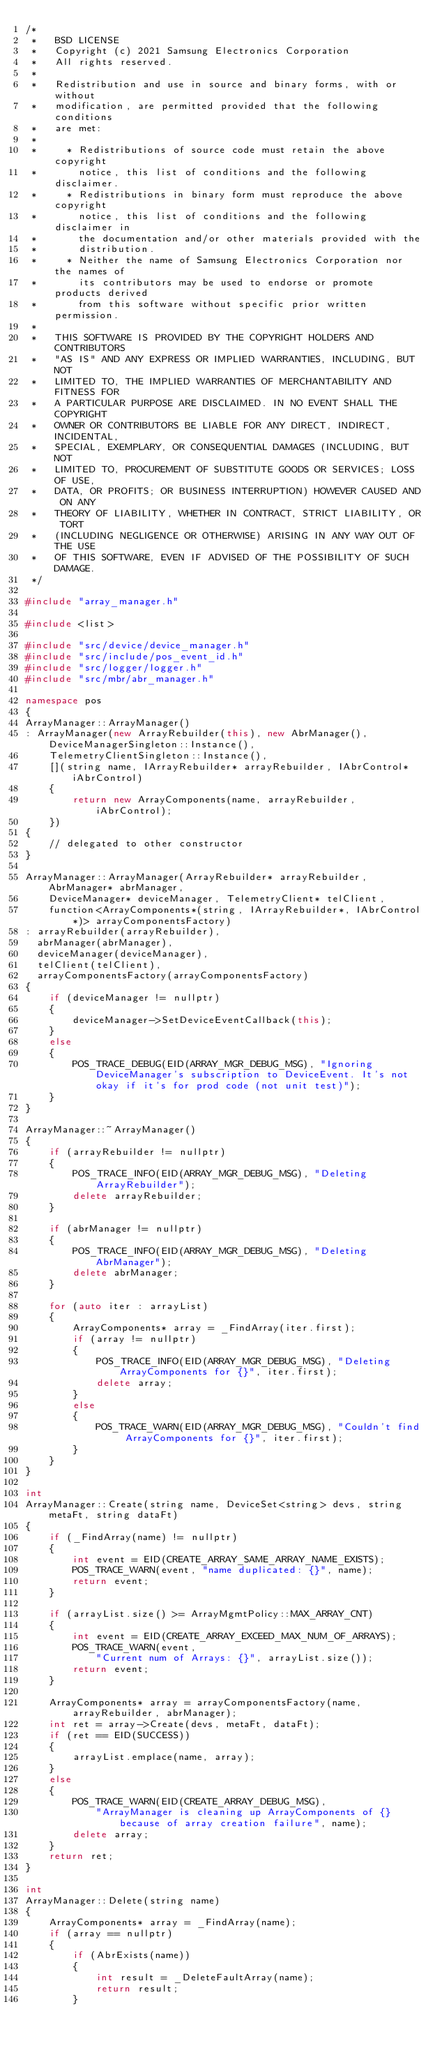<code> <loc_0><loc_0><loc_500><loc_500><_C++_>/*
 *   BSD LICENSE
 *   Copyright (c) 2021 Samsung Electronics Corporation
 *   All rights reserved.
 *
 *   Redistribution and use in source and binary forms, with or without
 *   modification, are permitted provided that the following conditions
 *   are met:
 *
 *     * Redistributions of source code must retain the above copyright
 *       notice, this list of conditions and the following disclaimer.
 *     * Redistributions in binary form must reproduce the above copyright
 *       notice, this list of conditions and the following disclaimer in
 *       the documentation and/or other materials provided with the
 *       distribution.
 *     * Neither the name of Samsung Electronics Corporation nor the names of
 *       its contributors may be used to endorse or promote products derived
 *       from this software without specific prior written permission.
 *
 *   THIS SOFTWARE IS PROVIDED BY THE COPYRIGHT HOLDERS AND CONTRIBUTORS
 *   "AS IS" AND ANY EXPRESS OR IMPLIED WARRANTIES, INCLUDING, BUT NOT
 *   LIMITED TO, THE IMPLIED WARRANTIES OF MERCHANTABILITY AND FITNESS FOR
 *   A PARTICULAR PURPOSE ARE DISCLAIMED. IN NO EVENT SHALL THE COPYRIGHT
 *   OWNER OR CONTRIBUTORS BE LIABLE FOR ANY DIRECT, INDIRECT, INCIDENTAL,
 *   SPECIAL, EXEMPLARY, OR CONSEQUENTIAL DAMAGES (INCLUDING, BUT NOT
 *   LIMITED TO, PROCUREMENT OF SUBSTITUTE GOODS OR SERVICES; LOSS OF USE,
 *   DATA, OR PROFITS; OR BUSINESS INTERRUPTION) HOWEVER CAUSED AND ON ANY
 *   THEORY OF LIABILITY, WHETHER IN CONTRACT, STRICT LIABILITY, OR TORT
 *   (INCLUDING NEGLIGENCE OR OTHERWISE) ARISING IN ANY WAY OUT OF THE USE
 *   OF THIS SOFTWARE, EVEN IF ADVISED OF THE POSSIBILITY OF SUCH DAMAGE.
 */

#include "array_manager.h"

#include <list>

#include "src/device/device_manager.h"
#include "src/include/pos_event_id.h"
#include "src/logger/logger.h"
#include "src/mbr/abr_manager.h"

namespace pos
{
ArrayManager::ArrayManager()
: ArrayManager(new ArrayRebuilder(this), new AbrManager(), DeviceManagerSingleton::Instance(),
    TelemetryClientSingleton::Instance(),
    [](string name, IArrayRebuilder* arrayRebuilder, IAbrControl* iAbrControl)
    {
        return new ArrayComponents(name, arrayRebuilder, iAbrControl);
    })
{
    // delegated to other constructor
}

ArrayManager::ArrayManager(ArrayRebuilder* arrayRebuilder, AbrManager* abrManager,
    DeviceManager* deviceManager, TelemetryClient* telClient,
    function<ArrayComponents*(string, IArrayRebuilder*, IAbrControl*)> arrayComponentsFactory)
: arrayRebuilder(arrayRebuilder),
  abrManager(abrManager),
  deviceManager(deviceManager),
  telClient(telClient),
  arrayComponentsFactory(arrayComponentsFactory)
{
    if (deviceManager != nullptr)
    {
        deviceManager->SetDeviceEventCallback(this);
    }
    else
    {
        POS_TRACE_DEBUG(EID(ARRAY_MGR_DEBUG_MSG), "Ignoring DeviceManager's subscription to DeviceEvent. It's not okay if it's for prod code (not unit test)");
    }
}

ArrayManager::~ArrayManager()
{
    if (arrayRebuilder != nullptr)
    {
        POS_TRACE_INFO(EID(ARRAY_MGR_DEBUG_MSG), "Deleting ArrayRebuilder");
        delete arrayRebuilder;
    }

    if (abrManager != nullptr)
    {
        POS_TRACE_INFO(EID(ARRAY_MGR_DEBUG_MSG), "Deleting AbrManager");
        delete abrManager;
    }

    for (auto iter : arrayList)
    {
        ArrayComponents* array = _FindArray(iter.first);
        if (array != nullptr)
        {
            POS_TRACE_INFO(EID(ARRAY_MGR_DEBUG_MSG), "Deleting ArrayComponents for {}", iter.first);
            delete array;
        }
        else
        {
            POS_TRACE_WARN(EID(ARRAY_MGR_DEBUG_MSG), "Couldn't find ArrayComponents for {}", iter.first);
        }
    }
}

int
ArrayManager::Create(string name, DeviceSet<string> devs, string metaFt, string dataFt)
{
    if (_FindArray(name) != nullptr)
    {
        int event = EID(CREATE_ARRAY_SAME_ARRAY_NAME_EXISTS);
        POS_TRACE_WARN(event, "name duplicated: {}", name);
        return event;
    }

    if (arrayList.size() >= ArrayMgmtPolicy::MAX_ARRAY_CNT)
    {
        int event = EID(CREATE_ARRAY_EXCEED_MAX_NUM_OF_ARRAYS);
        POS_TRACE_WARN(event,
            "Current num of Arrays: {}", arrayList.size());
        return event;
    }

    ArrayComponents* array = arrayComponentsFactory(name, arrayRebuilder, abrManager);
    int ret = array->Create(devs, metaFt, dataFt);
    if (ret == EID(SUCCESS))
    {
        arrayList.emplace(name, array);
    }
    else
    {
        POS_TRACE_WARN(EID(CREATE_ARRAY_DEBUG_MSG),
            "ArrayManager is cleaning up ArrayComponents of {} because of array creation failure", name);
        delete array;
    }
    return ret;
}

int
ArrayManager::Delete(string name)
{
    ArrayComponents* array = _FindArray(name);
    if (array == nullptr)
    {
        if (AbrExists(name))
        {
            int result = _DeleteFaultArray(name);
            return result;
        }</code> 